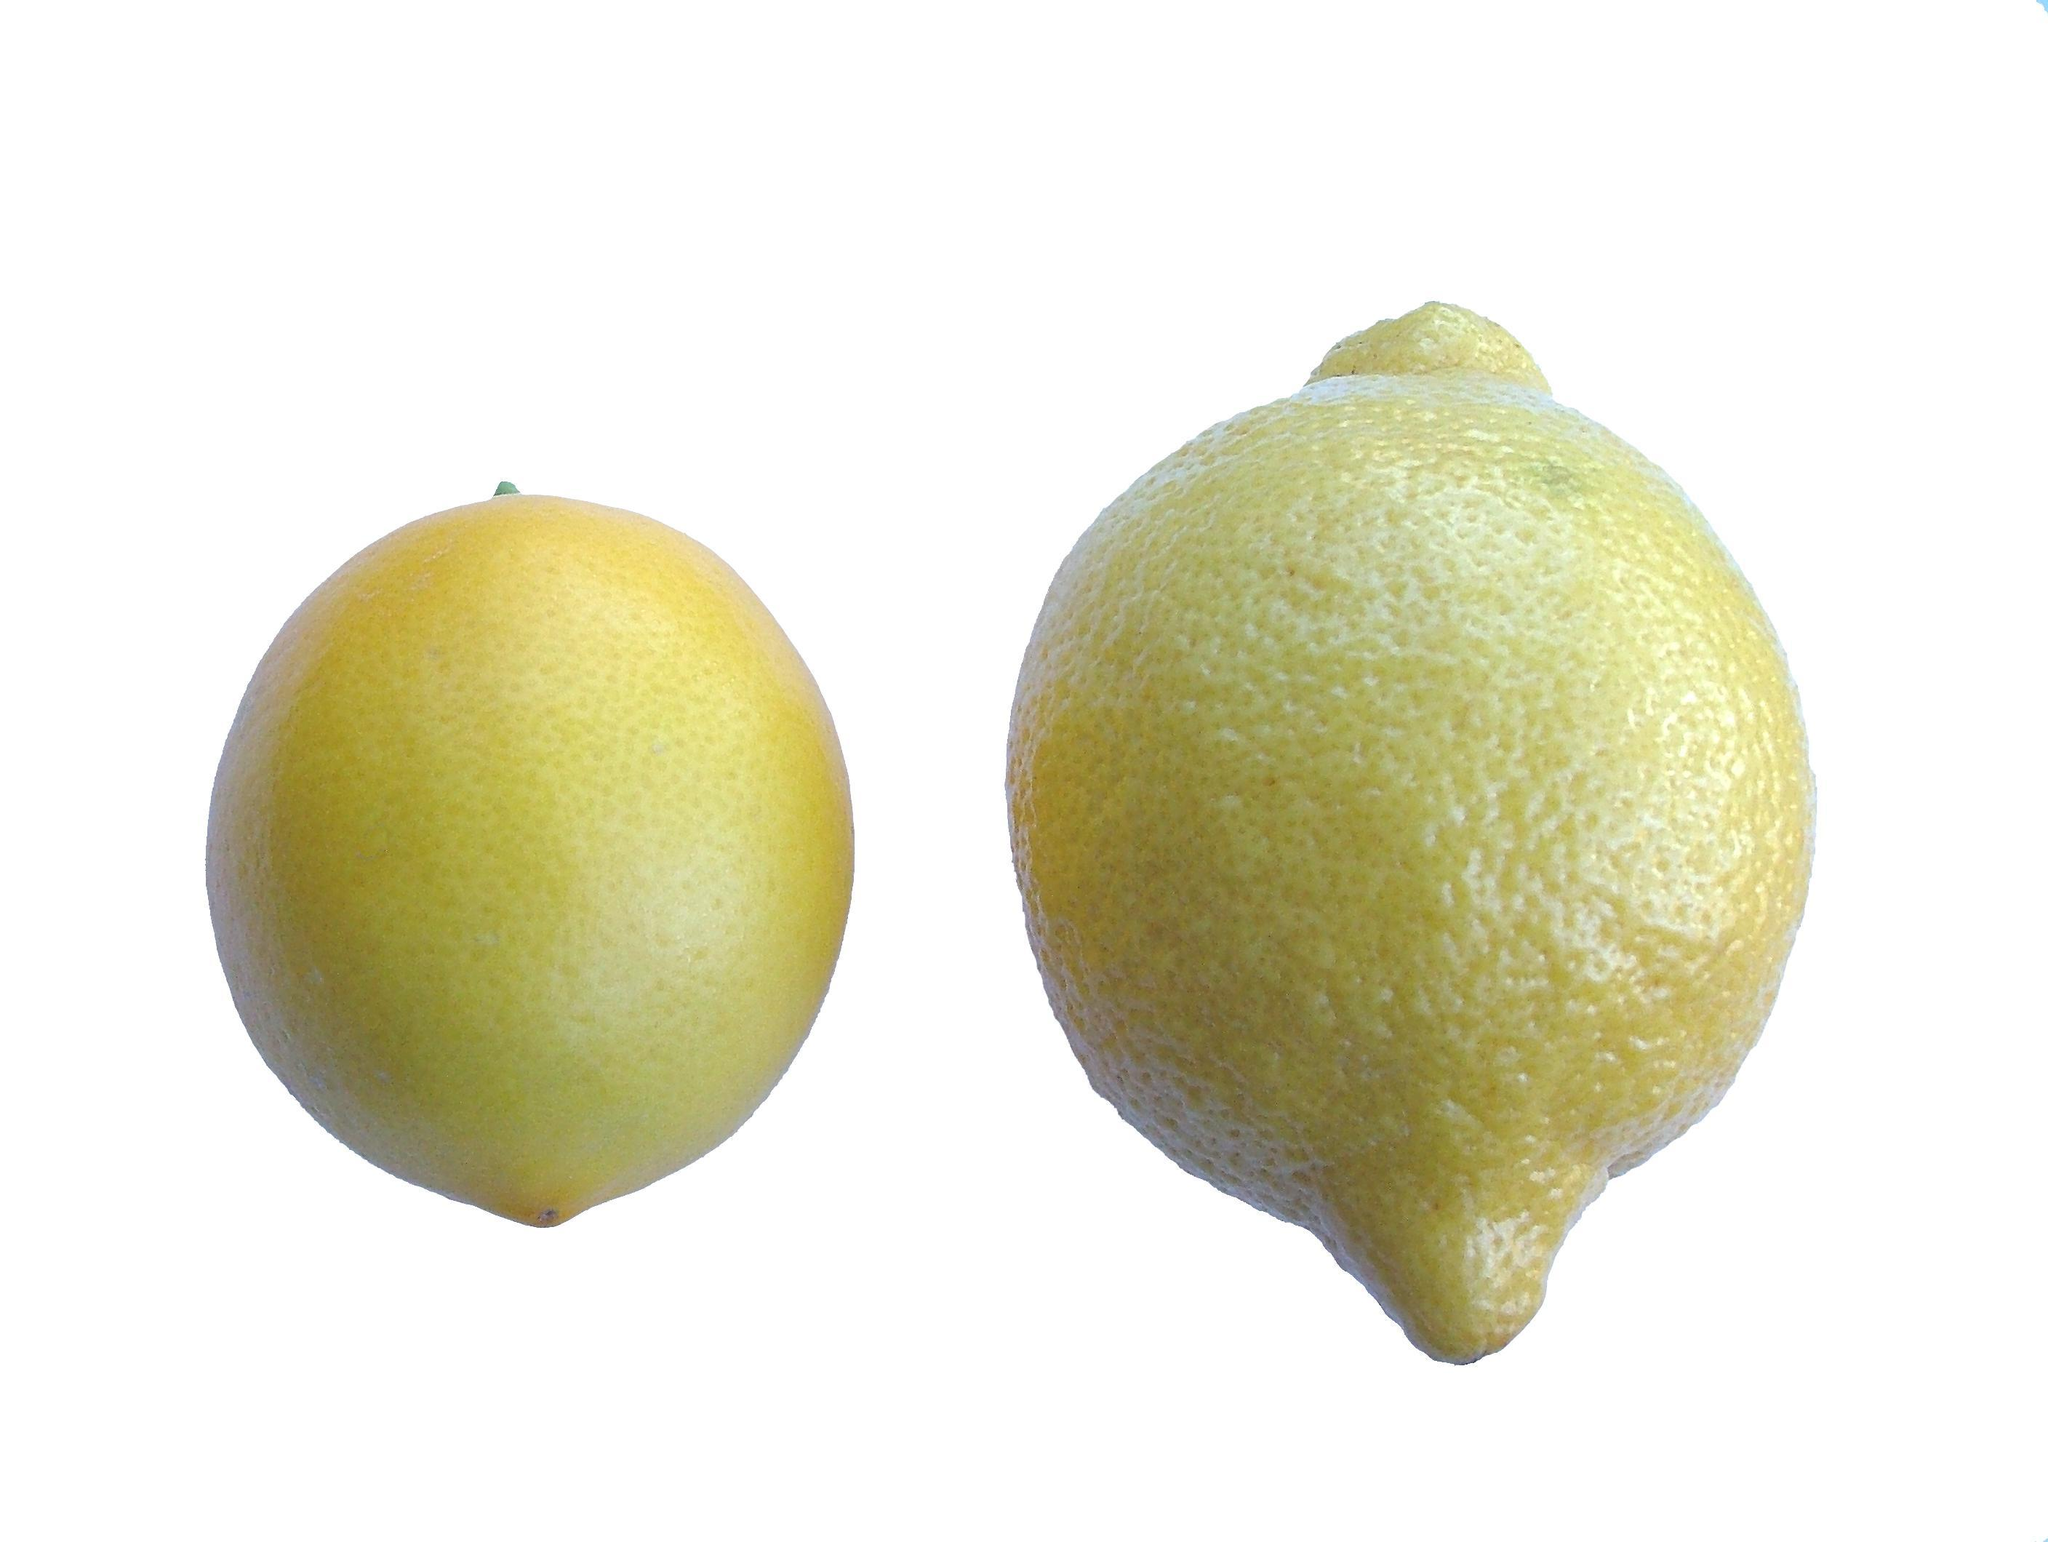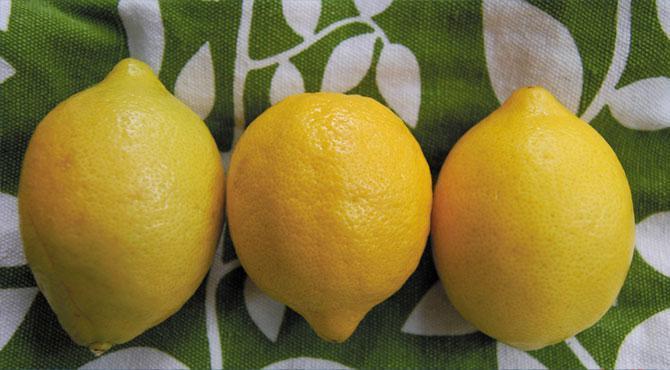The first image is the image on the left, the second image is the image on the right. Considering the images on both sides, is "All of the fruit is whole and is not on a tree." valid? Answer yes or no. Yes. The first image is the image on the left, the second image is the image on the right. Given the left and right images, does the statement "None of the lemons in the images have been sliced open." hold true? Answer yes or no. Yes. 